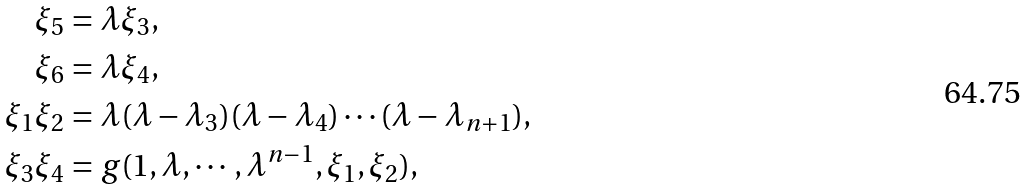Convert formula to latex. <formula><loc_0><loc_0><loc_500><loc_500>\xi _ { 5 } & = \lambda \xi _ { 3 } , \\ \xi _ { 6 } & = \lambda \xi _ { 4 } , \\ \xi _ { 1 } \xi _ { 2 } & = \lambda ( \lambda - \lambda _ { 3 } ) ( \lambda - \lambda _ { 4 } ) \cdots ( \lambda - \lambda _ { n + 1 } ) , \\ \xi _ { 3 } \xi _ { 4 } & = g ( 1 , \lambda , \cdots , \lambda ^ { n - 1 } , \xi _ { 1 } , \xi _ { 2 } ) ,</formula> 